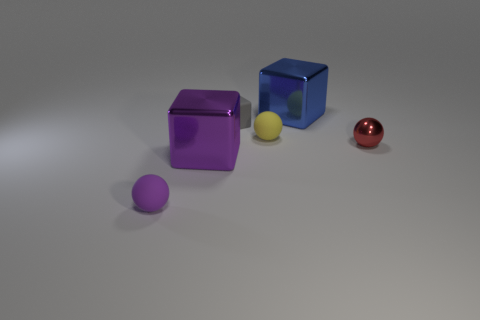Can you describe the sizes of the objects in relation to each other? Certainly, there are two larger cubes, with one being significantly bigger than the other, and two smaller spheres, with one sphere being distinctly smaller than all the other objects. Do the objects give any indication about the lighting in the scene? Yes, the objects have shadows cast to the right, suggesting a light source to the left of the scene. The softness and direction of the shadows provide hints about the light's position and nature. 